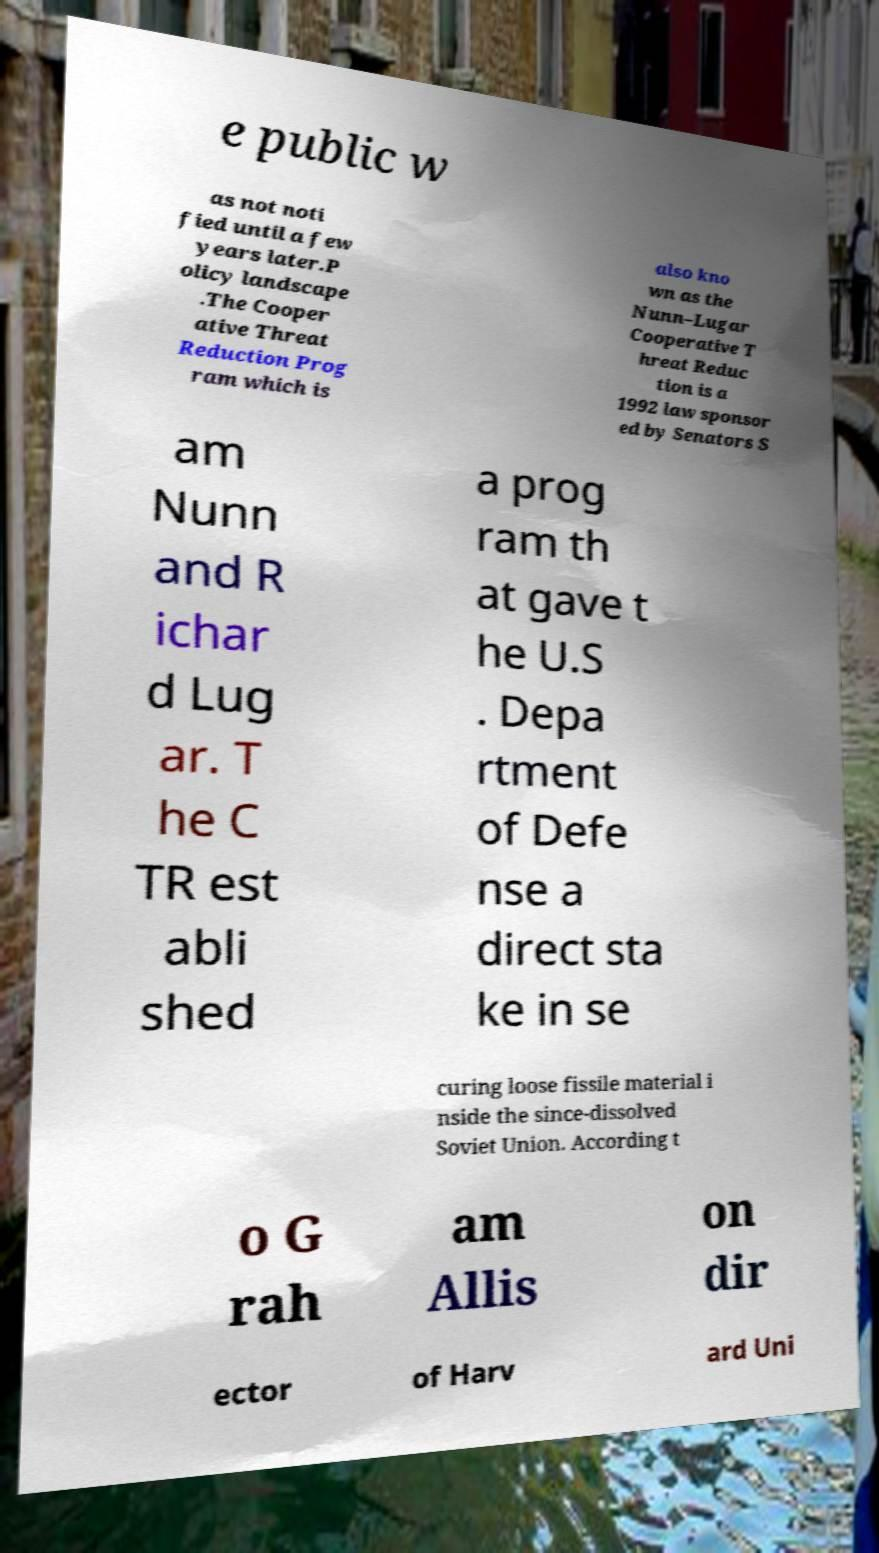Could you assist in decoding the text presented in this image and type it out clearly? e public w as not noti fied until a few years later.P olicy landscape .The Cooper ative Threat Reduction Prog ram which is also kno wn as the Nunn–Lugar Cooperative T hreat Reduc tion is a 1992 law sponsor ed by Senators S am Nunn and R ichar d Lug ar. T he C TR est abli shed a prog ram th at gave t he U.S . Depa rtment of Defe nse a direct sta ke in se curing loose fissile material i nside the since-dissolved Soviet Union. According t o G rah am Allis on dir ector of Harv ard Uni 